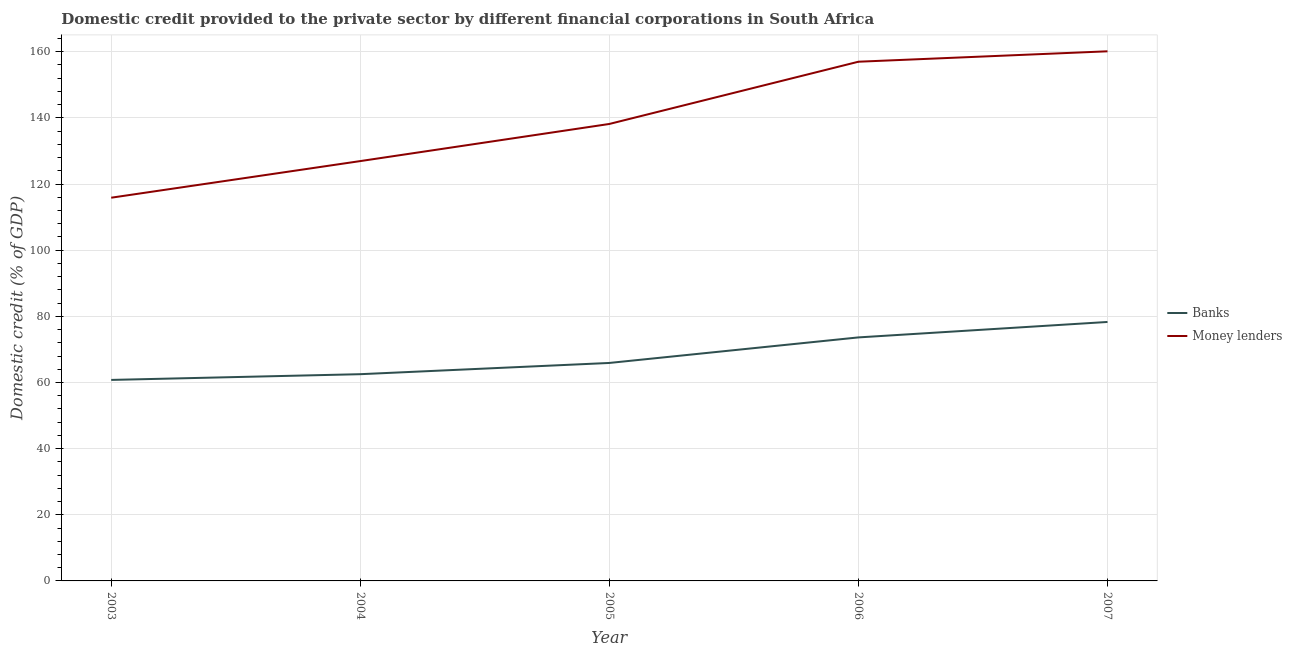How many different coloured lines are there?
Offer a very short reply. 2. Does the line corresponding to domestic credit provided by money lenders intersect with the line corresponding to domestic credit provided by banks?
Keep it short and to the point. No. Is the number of lines equal to the number of legend labels?
Your answer should be very brief. Yes. What is the domestic credit provided by banks in 2007?
Your answer should be compact. 78.29. Across all years, what is the maximum domestic credit provided by banks?
Your answer should be very brief. 78.29. Across all years, what is the minimum domestic credit provided by banks?
Keep it short and to the point. 60.77. In which year was the domestic credit provided by money lenders maximum?
Give a very brief answer. 2007. What is the total domestic credit provided by money lenders in the graph?
Give a very brief answer. 698.05. What is the difference between the domestic credit provided by banks in 2005 and that in 2006?
Your answer should be very brief. -7.72. What is the difference between the domestic credit provided by banks in 2003 and the domestic credit provided by money lenders in 2007?
Your answer should be very brief. -99.35. What is the average domestic credit provided by banks per year?
Your response must be concise. 68.22. In the year 2005, what is the difference between the domestic credit provided by money lenders and domestic credit provided by banks?
Provide a succinct answer. 72.26. What is the ratio of the domestic credit provided by banks in 2005 to that in 2007?
Your answer should be compact. 0.84. Is the difference between the domestic credit provided by money lenders in 2005 and 2006 greater than the difference between the domestic credit provided by banks in 2005 and 2006?
Your response must be concise. No. What is the difference between the highest and the second highest domestic credit provided by money lenders?
Give a very brief answer. 3.15. What is the difference between the highest and the lowest domestic credit provided by money lenders?
Your response must be concise. 44.26. In how many years, is the domestic credit provided by banks greater than the average domestic credit provided by banks taken over all years?
Provide a short and direct response. 2. How many lines are there?
Your answer should be very brief. 2. How many years are there in the graph?
Offer a terse response. 5. What is the difference between two consecutive major ticks on the Y-axis?
Your answer should be compact. 20. Are the values on the major ticks of Y-axis written in scientific E-notation?
Your response must be concise. No. Does the graph contain grids?
Your answer should be very brief. Yes. Where does the legend appear in the graph?
Your response must be concise. Center right. How are the legend labels stacked?
Your answer should be compact. Vertical. What is the title of the graph?
Your response must be concise. Domestic credit provided to the private sector by different financial corporations in South Africa. Does "Enforce a contract" appear as one of the legend labels in the graph?
Your answer should be compact. No. What is the label or title of the Y-axis?
Make the answer very short. Domestic credit (% of GDP). What is the Domestic credit (% of GDP) of Banks in 2003?
Make the answer very short. 60.77. What is the Domestic credit (% of GDP) in Money lenders in 2003?
Provide a short and direct response. 115.86. What is the Domestic credit (% of GDP) in Banks in 2004?
Provide a succinct answer. 62.5. What is the Domestic credit (% of GDP) in Money lenders in 2004?
Your answer should be compact. 126.93. What is the Domestic credit (% of GDP) of Banks in 2005?
Your answer should be very brief. 65.9. What is the Domestic credit (% of GDP) of Money lenders in 2005?
Your answer should be compact. 138.16. What is the Domestic credit (% of GDP) of Banks in 2006?
Keep it short and to the point. 73.62. What is the Domestic credit (% of GDP) of Money lenders in 2006?
Offer a terse response. 156.98. What is the Domestic credit (% of GDP) in Banks in 2007?
Provide a succinct answer. 78.29. What is the Domestic credit (% of GDP) of Money lenders in 2007?
Ensure brevity in your answer.  160.12. Across all years, what is the maximum Domestic credit (% of GDP) of Banks?
Provide a short and direct response. 78.29. Across all years, what is the maximum Domestic credit (% of GDP) in Money lenders?
Provide a succinct answer. 160.12. Across all years, what is the minimum Domestic credit (% of GDP) of Banks?
Your answer should be very brief. 60.77. Across all years, what is the minimum Domestic credit (% of GDP) of Money lenders?
Offer a very short reply. 115.86. What is the total Domestic credit (% of GDP) in Banks in the graph?
Provide a short and direct response. 341.1. What is the total Domestic credit (% of GDP) of Money lenders in the graph?
Offer a very short reply. 698.05. What is the difference between the Domestic credit (% of GDP) of Banks in 2003 and that in 2004?
Give a very brief answer. -1.73. What is the difference between the Domestic credit (% of GDP) in Money lenders in 2003 and that in 2004?
Provide a succinct answer. -11.07. What is the difference between the Domestic credit (% of GDP) in Banks in 2003 and that in 2005?
Provide a succinct answer. -5.13. What is the difference between the Domestic credit (% of GDP) in Money lenders in 2003 and that in 2005?
Keep it short and to the point. -22.3. What is the difference between the Domestic credit (% of GDP) in Banks in 2003 and that in 2006?
Your answer should be very brief. -12.85. What is the difference between the Domestic credit (% of GDP) of Money lenders in 2003 and that in 2006?
Make the answer very short. -41.11. What is the difference between the Domestic credit (% of GDP) in Banks in 2003 and that in 2007?
Keep it short and to the point. -17.52. What is the difference between the Domestic credit (% of GDP) of Money lenders in 2003 and that in 2007?
Ensure brevity in your answer.  -44.26. What is the difference between the Domestic credit (% of GDP) in Banks in 2004 and that in 2005?
Offer a very short reply. -3.4. What is the difference between the Domestic credit (% of GDP) in Money lenders in 2004 and that in 2005?
Offer a very short reply. -11.23. What is the difference between the Domestic credit (% of GDP) of Banks in 2004 and that in 2006?
Give a very brief answer. -11.12. What is the difference between the Domestic credit (% of GDP) in Money lenders in 2004 and that in 2006?
Make the answer very short. -30.04. What is the difference between the Domestic credit (% of GDP) of Banks in 2004 and that in 2007?
Keep it short and to the point. -15.79. What is the difference between the Domestic credit (% of GDP) in Money lenders in 2004 and that in 2007?
Provide a short and direct response. -33.19. What is the difference between the Domestic credit (% of GDP) of Banks in 2005 and that in 2006?
Provide a short and direct response. -7.72. What is the difference between the Domestic credit (% of GDP) of Money lenders in 2005 and that in 2006?
Ensure brevity in your answer.  -18.82. What is the difference between the Domestic credit (% of GDP) in Banks in 2005 and that in 2007?
Keep it short and to the point. -12.39. What is the difference between the Domestic credit (% of GDP) in Money lenders in 2005 and that in 2007?
Give a very brief answer. -21.97. What is the difference between the Domestic credit (% of GDP) in Banks in 2006 and that in 2007?
Offer a very short reply. -4.67. What is the difference between the Domestic credit (% of GDP) of Money lenders in 2006 and that in 2007?
Keep it short and to the point. -3.15. What is the difference between the Domestic credit (% of GDP) in Banks in 2003 and the Domestic credit (% of GDP) in Money lenders in 2004?
Your answer should be very brief. -66.16. What is the difference between the Domestic credit (% of GDP) in Banks in 2003 and the Domestic credit (% of GDP) in Money lenders in 2005?
Offer a terse response. -77.39. What is the difference between the Domestic credit (% of GDP) of Banks in 2003 and the Domestic credit (% of GDP) of Money lenders in 2006?
Make the answer very short. -96.2. What is the difference between the Domestic credit (% of GDP) in Banks in 2003 and the Domestic credit (% of GDP) in Money lenders in 2007?
Your response must be concise. -99.35. What is the difference between the Domestic credit (% of GDP) of Banks in 2004 and the Domestic credit (% of GDP) of Money lenders in 2005?
Your answer should be very brief. -75.65. What is the difference between the Domestic credit (% of GDP) of Banks in 2004 and the Domestic credit (% of GDP) of Money lenders in 2006?
Offer a very short reply. -94.47. What is the difference between the Domestic credit (% of GDP) of Banks in 2004 and the Domestic credit (% of GDP) of Money lenders in 2007?
Offer a very short reply. -97.62. What is the difference between the Domestic credit (% of GDP) in Banks in 2005 and the Domestic credit (% of GDP) in Money lenders in 2006?
Keep it short and to the point. -91.07. What is the difference between the Domestic credit (% of GDP) in Banks in 2005 and the Domestic credit (% of GDP) in Money lenders in 2007?
Your response must be concise. -94.22. What is the difference between the Domestic credit (% of GDP) in Banks in 2006 and the Domestic credit (% of GDP) in Money lenders in 2007?
Make the answer very short. -86.5. What is the average Domestic credit (% of GDP) in Banks per year?
Provide a succinct answer. 68.22. What is the average Domestic credit (% of GDP) of Money lenders per year?
Your answer should be very brief. 139.61. In the year 2003, what is the difference between the Domestic credit (% of GDP) in Banks and Domestic credit (% of GDP) in Money lenders?
Give a very brief answer. -55.09. In the year 2004, what is the difference between the Domestic credit (% of GDP) in Banks and Domestic credit (% of GDP) in Money lenders?
Your answer should be compact. -64.43. In the year 2005, what is the difference between the Domestic credit (% of GDP) of Banks and Domestic credit (% of GDP) of Money lenders?
Your response must be concise. -72.26. In the year 2006, what is the difference between the Domestic credit (% of GDP) of Banks and Domestic credit (% of GDP) of Money lenders?
Provide a succinct answer. -83.35. In the year 2007, what is the difference between the Domestic credit (% of GDP) of Banks and Domestic credit (% of GDP) of Money lenders?
Your answer should be very brief. -81.83. What is the ratio of the Domestic credit (% of GDP) in Banks in 2003 to that in 2004?
Provide a short and direct response. 0.97. What is the ratio of the Domestic credit (% of GDP) of Money lenders in 2003 to that in 2004?
Offer a very short reply. 0.91. What is the ratio of the Domestic credit (% of GDP) of Banks in 2003 to that in 2005?
Offer a terse response. 0.92. What is the ratio of the Domestic credit (% of GDP) of Money lenders in 2003 to that in 2005?
Keep it short and to the point. 0.84. What is the ratio of the Domestic credit (% of GDP) in Banks in 2003 to that in 2006?
Offer a very short reply. 0.83. What is the ratio of the Domestic credit (% of GDP) in Money lenders in 2003 to that in 2006?
Provide a succinct answer. 0.74. What is the ratio of the Domestic credit (% of GDP) in Banks in 2003 to that in 2007?
Offer a terse response. 0.78. What is the ratio of the Domestic credit (% of GDP) in Money lenders in 2003 to that in 2007?
Offer a terse response. 0.72. What is the ratio of the Domestic credit (% of GDP) in Banks in 2004 to that in 2005?
Offer a terse response. 0.95. What is the ratio of the Domestic credit (% of GDP) in Money lenders in 2004 to that in 2005?
Provide a succinct answer. 0.92. What is the ratio of the Domestic credit (% of GDP) of Banks in 2004 to that in 2006?
Your answer should be very brief. 0.85. What is the ratio of the Domestic credit (% of GDP) of Money lenders in 2004 to that in 2006?
Your answer should be compact. 0.81. What is the ratio of the Domestic credit (% of GDP) in Banks in 2004 to that in 2007?
Your response must be concise. 0.8. What is the ratio of the Domestic credit (% of GDP) of Money lenders in 2004 to that in 2007?
Provide a succinct answer. 0.79. What is the ratio of the Domestic credit (% of GDP) of Banks in 2005 to that in 2006?
Offer a terse response. 0.9. What is the ratio of the Domestic credit (% of GDP) of Money lenders in 2005 to that in 2006?
Provide a short and direct response. 0.88. What is the ratio of the Domestic credit (% of GDP) in Banks in 2005 to that in 2007?
Provide a succinct answer. 0.84. What is the ratio of the Domestic credit (% of GDP) in Money lenders in 2005 to that in 2007?
Make the answer very short. 0.86. What is the ratio of the Domestic credit (% of GDP) in Banks in 2006 to that in 2007?
Your answer should be very brief. 0.94. What is the ratio of the Domestic credit (% of GDP) in Money lenders in 2006 to that in 2007?
Provide a short and direct response. 0.98. What is the difference between the highest and the second highest Domestic credit (% of GDP) of Banks?
Give a very brief answer. 4.67. What is the difference between the highest and the second highest Domestic credit (% of GDP) in Money lenders?
Provide a short and direct response. 3.15. What is the difference between the highest and the lowest Domestic credit (% of GDP) of Banks?
Offer a terse response. 17.52. What is the difference between the highest and the lowest Domestic credit (% of GDP) of Money lenders?
Your response must be concise. 44.26. 